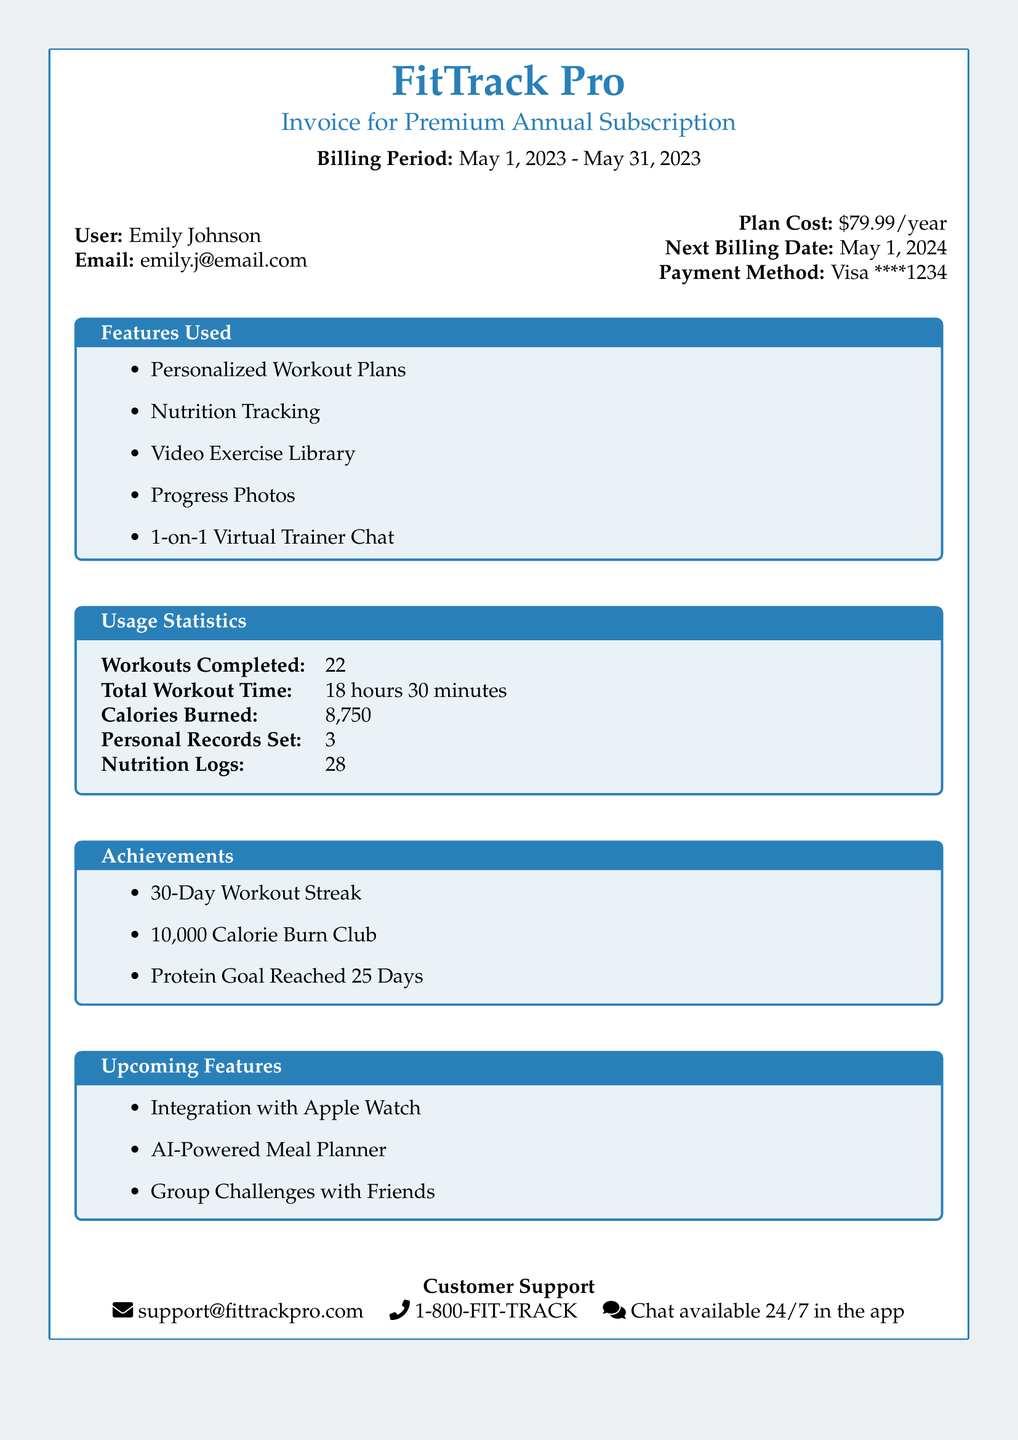What is the billing period? The billing period is clearly stated in the document as the timeframe for the subscription service.
Answer: May 1, 2023 - May 31, 2023 How much does the plan cost? The plan cost is specifically listed, providing clear financial information about the subscription.
Answer: $79.99/year What is the total workout time? Total workout time is a key performance indicator that shows the amount of time spent on workouts.
Answer: 18 hours 30 minutes How many workouts were completed? This indicates the total number of workout sessions logged during the billing period.
Answer: 22 What is one achievement listed? Achievements showcase the user’s progress and milestones achieved during the subscription period.
Answer: 30-Day Workout Streak When is the next billing date? The next billing date is mentioned in the document, giving users information about upcoming payments.
Answer: May 1, 2024 What payment method was used? The payment method informs users about the transaction details related to their subscription.
Answer: Visa ****1234 What are two upcoming features? Upcoming features highlight enhancements that users can expect in the future, reflecting the app's development.
Answer: Integration with Apple Watch, AI-Powered Meal Planner How many calories were burned? Calories burned provide insight into the effectiveness of workout sessions throughout the billing period.
Answer: 8,750 